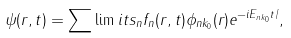Convert formula to latex. <formula><loc_0><loc_0><loc_500><loc_500>\psi ( { r } , t ) = \sum \lim i t s _ { n } { f _ { n } ( { r } , t ) \phi _ { n { k } _ { 0 } } ( { r } ) e ^ { - i E _ { n { k } _ { 0 } } t / } } ,</formula> 